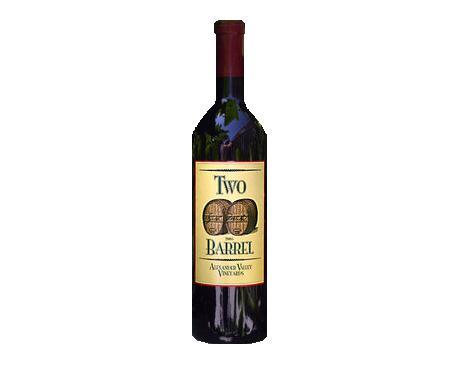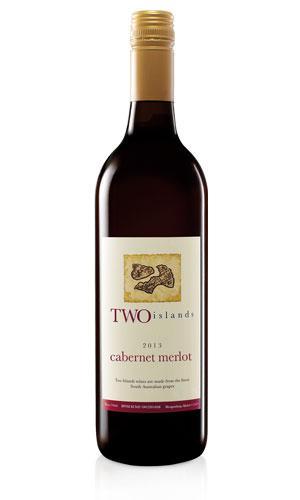The first image is the image on the left, the second image is the image on the right. Assess this claim about the two images: "One image shows a bottle of wine with a black background.". Correct or not? Answer yes or no. No. 